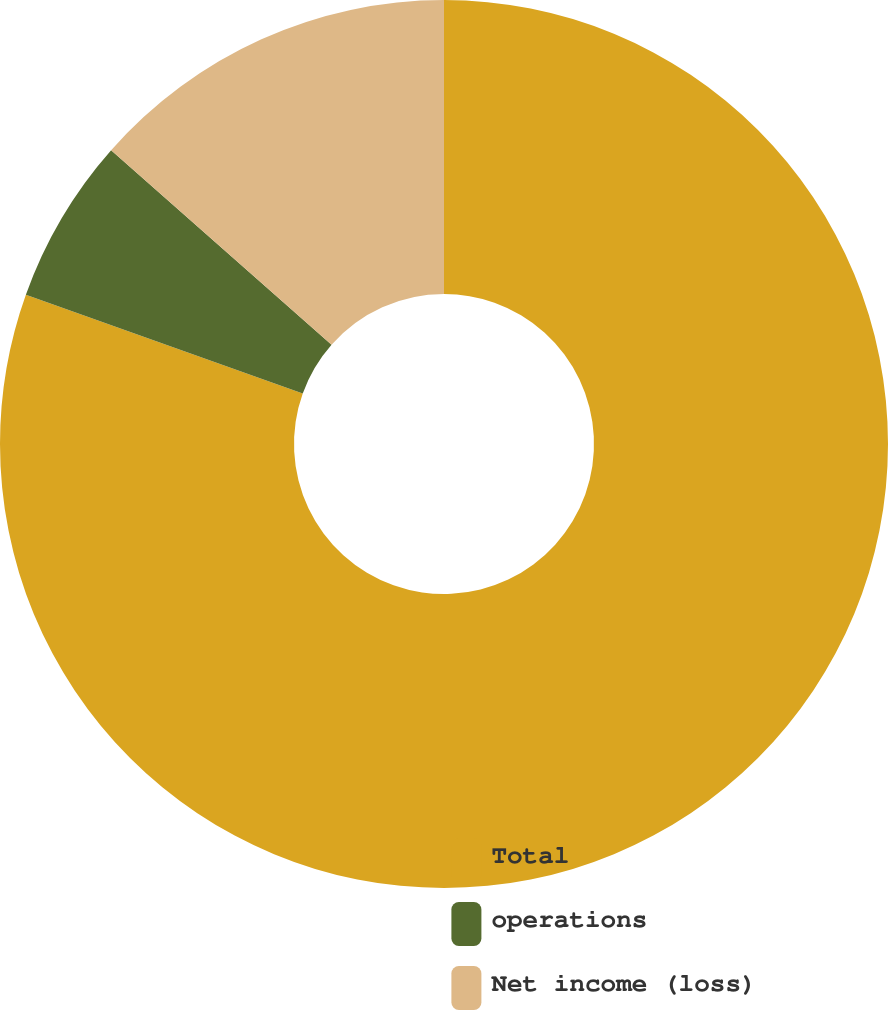Convert chart to OTSL. <chart><loc_0><loc_0><loc_500><loc_500><pie_chart><fcel>Total<fcel>operations<fcel>Net income (loss)<nl><fcel>80.46%<fcel>6.05%<fcel>13.49%<nl></chart> 